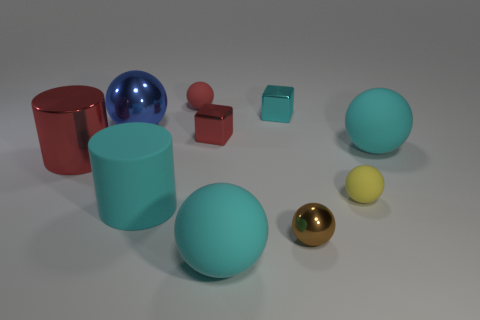Subtract all brown spheres. How many spheres are left? 5 Subtract all small brown shiny spheres. How many spheres are left? 5 Subtract all brown balls. Subtract all green cubes. How many balls are left? 5 Subtract all cubes. How many objects are left? 8 Add 6 tiny cubes. How many tiny cubes exist? 8 Subtract 0 yellow cubes. How many objects are left? 10 Subtract all tiny cyan metallic blocks. Subtract all red things. How many objects are left? 6 Add 9 tiny cyan blocks. How many tiny cyan blocks are left? 10 